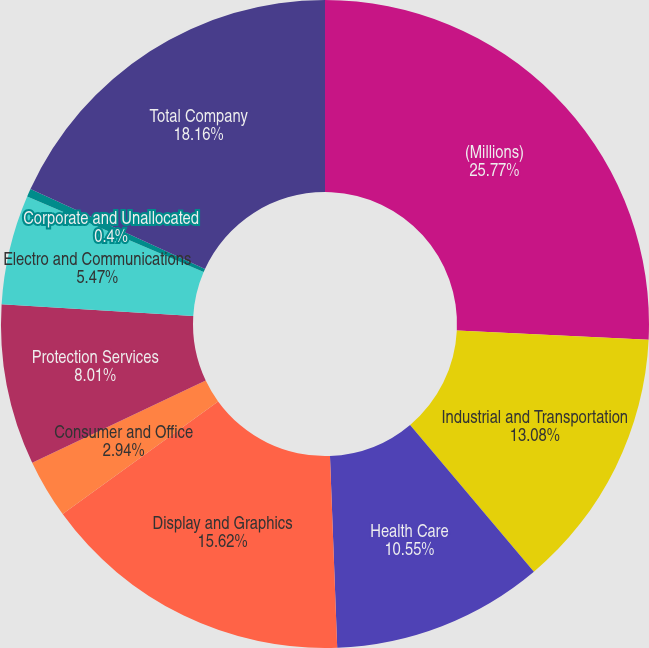Convert chart. <chart><loc_0><loc_0><loc_500><loc_500><pie_chart><fcel>(Millions)<fcel>Industrial and Transportation<fcel>Health Care<fcel>Display and Graphics<fcel>Consumer and Office<fcel>Protection Services<fcel>Electro and Communications<fcel>Corporate and Unallocated<fcel>Total Company<nl><fcel>25.77%<fcel>13.08%<fcel>10.55%<fcel>15.62%<fcel>2.94%<fcel>8.01%<fcel>5.47%<fcel>0.4%<fcel>18.16%<nl></chart> 